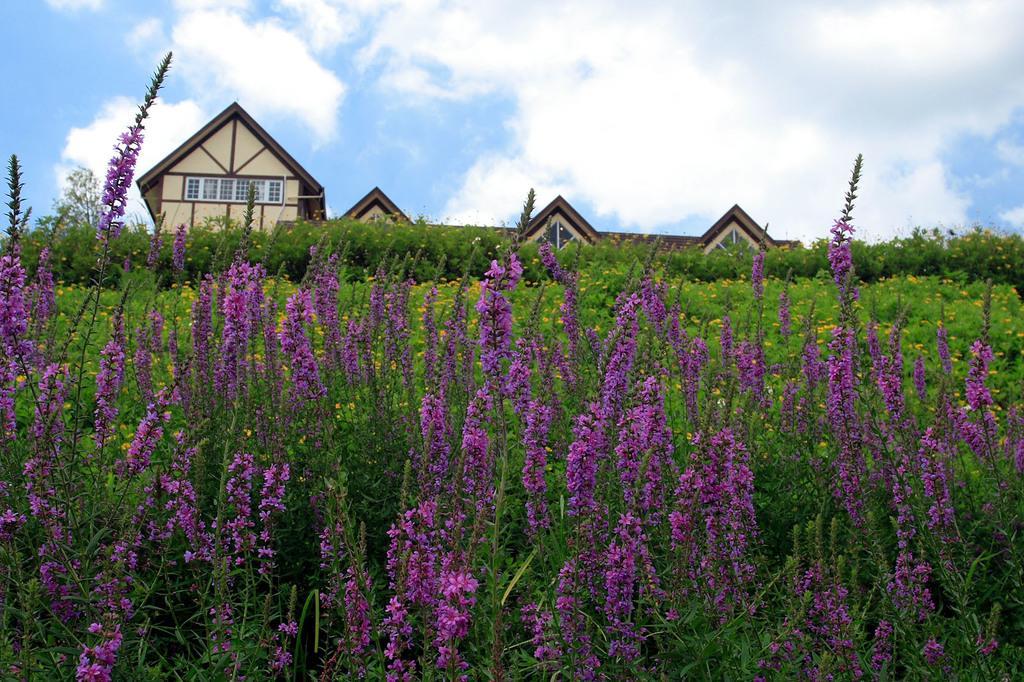Please provide a concise description of this image. In the image we can see a building and this is a window. Here we can see tiny flowers, purple in color. Here we can see plant and cloudy pale blue sky. 